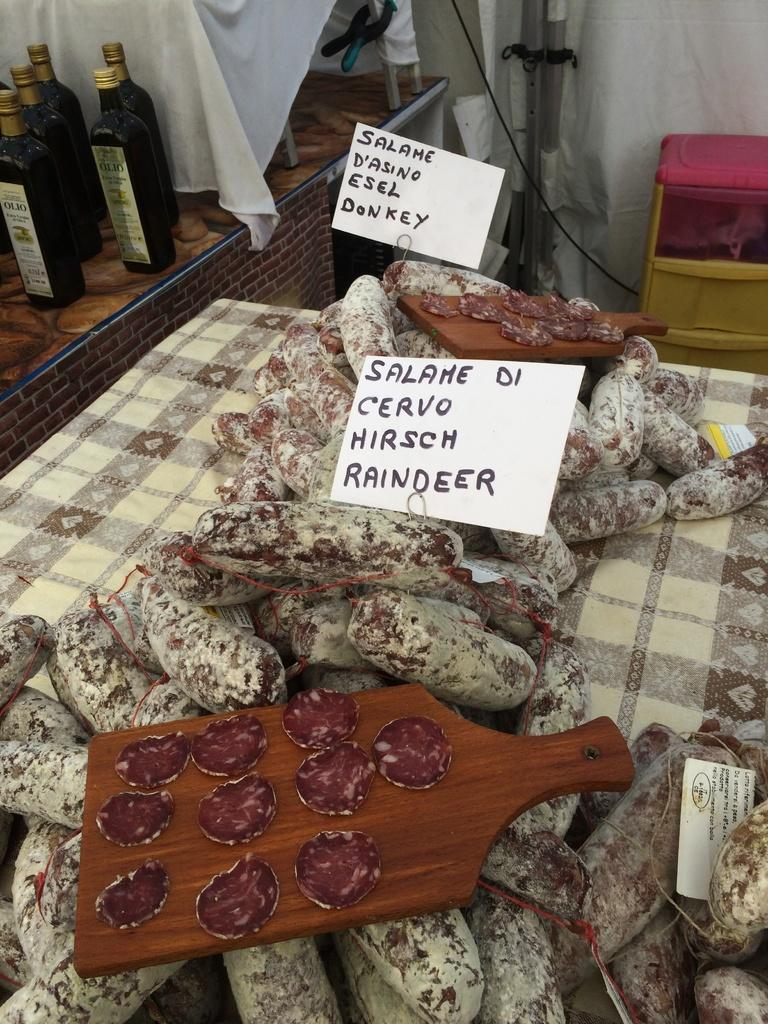Provide a one-sentence caption for the provided image. a bunch of salame di cervo on op of a kitchen table. 